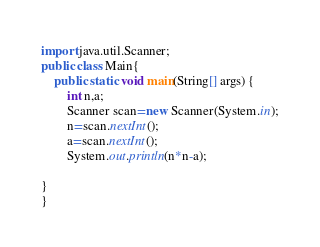<code> <loc_0><loc_0><loc_500><loc_500><_Java_>import java.util.Scanner;
public class Main{
	public static void main(String[] args) {
		int n,a;
		Scanner scan=new Scanner(System.in);
		n=scan.nextInt();
		a=scan.nextInt();
		System.out.println(n*n-a);
		
}
}
</code> 